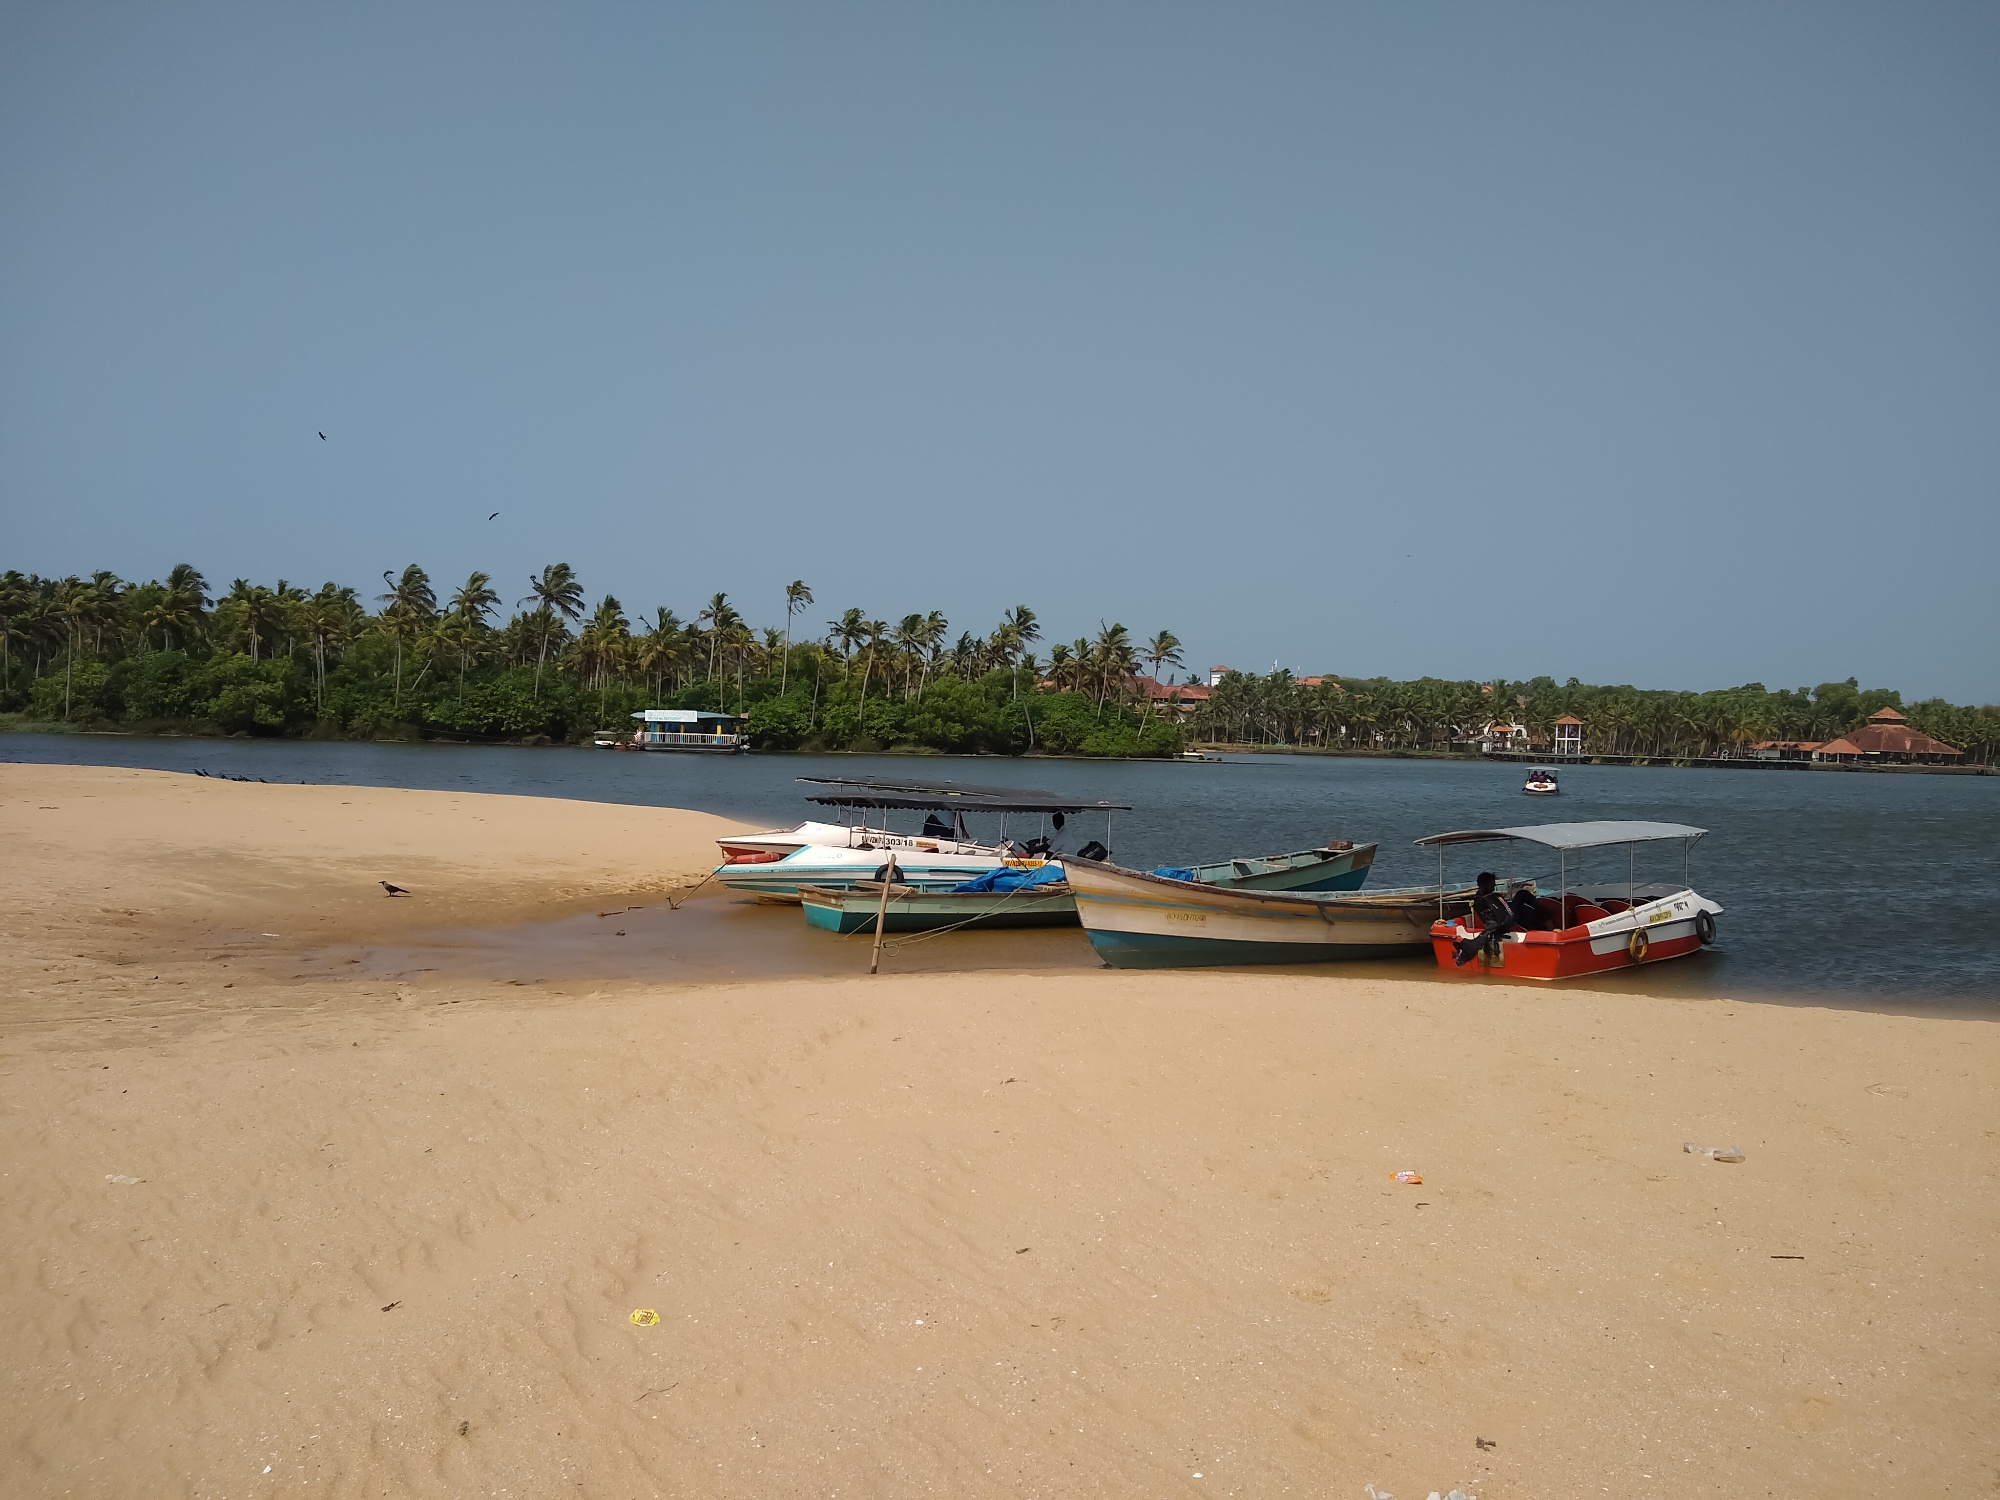What activities do you think the locals engage in here? Based on the presence of the boats and the serene beach setting, it's likely that the locals engage in fishing as a primary activity. The boats suggest that fishing trips, possibly both for local sustenance and commercial purposes, are common. Additionally, given the idyllic scenery, the area might also attract some tourism, with activities such as boat rides, beachside relaxation, and possibly local markets lining the shore. The palm-fringed coast might also be a spot for families to gather and children to play, especially during the cooler parts of the day. Describe a day in the life of a fisherman from this village. In this coastal village, a fisherman's day starts early, often before dawn. The fisherman prepares his boat and checks his fishing gear meticulously, ensuring everything is in place for a productive day at sea. As the first light of dawn breaks, he sets out onto the open water, his wooden boat cutting through the calm waves. The morning is spent casting nets or lines into the sea, often accompanied by the calls of seabirds and the gentle sound of breaking waves. Midday might involve a break to enjoy a simple meal while drifting on the water or anchored near the shore.

In the afternoon, the fisherman returns with the day's catch, which he then sorts and prepares for sale. Back on land, the fish might be sold directly from the beach to local buyers, at a market stall, or perhaps even to a small family-owned restaurant. The late afternoon is a time for rest, mending nets, and sharing stories with fellow fishermen. As the evening descends, the fisherman may help his family with other tasks or spend time socializing with the community, enjoying the simple yet fulfilling life of a coastal dweller. If these boats could talk, what kind of stories would they tell? Each boat would have a treasure trove of stories to share, woven with the threads of adventure, struggle, and community. They would speak of early mornings shrouded in mist, gliding silently over waters teeming with fish. Tales of close calls with summer storms, where heavy rains and fierce winds tested their resilience, would be recounted with a mix of pride and trepidation. They might tell of poignant moments, like the lone boat returning with a bountiful catch after a season of scarcity, bringing hope and sustenance to the village.

The boats could share stories of jubilation during festival times, when they are adorned with vibrant decorations and taken out for celebratory parades. They'd also have narratives of companionship, being anchored side by side, exchanging gentle creaks and groans as their owners cheerfully exchanged banter and news from neighboring shores.

Beyond the sea, the boats would recount the serene, almost meditative moments of waiting on the beach, feeling the warm sand against their hulls and witnessing the day-to-day life of the coastal community unfold around them. Their stories would be a rich tapestry of human endeavor, nature’s whims, and the enduring spirit of the sea. 